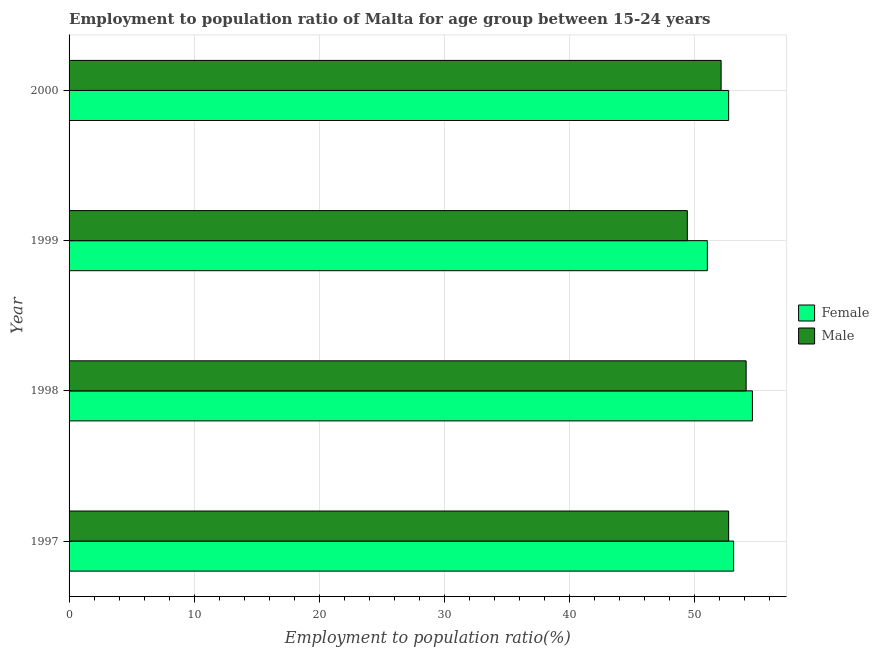How many different coloured bars are there?
Give a very brief answer. 2. Are the number of bars per tick equal to the number of legend labels?
Your answer should be very brief. Yes. How many bars are there on the 2nd tick from the top?
Offer a terse response. 2. How many bars are there on the 3rd tick from the bottom?
Your response must be concise. 2. In how many cases, is the number of bars for a given year not equal to the number of legend labels?
Provide a succinct answer. 0. What is the employment to population ratio(male) in 1997?
Offer a terse response. 52.7. Across all years, what is the maximum employment to population ratio(male)?
Your answer should be compact. 54.1. Across all years, what is the minimum employment to population ratio(female)?
Ensure brevity in your answer.  51. In which year was the employment to population ratio(female) maximum?
Your answer should be very brief. 1998. In which year was the employment to population ratio(male) minimum?
Provide a succinct answer. 1999. What is the total employment to population ratio(female) in the graph?
Your answer should be compact. 211.4. What is the difference between the employment to population ratio(male) in 1997 and that in 1998?
Ensure brevity in your answer.  -1.4. What is the difference between the employment to population ratio(female) in 2000 and the employment to population ratio(male) in 1998?
Provide a short and direct response. -1.4. What is the average employment to population ratio(male) per year?
Ensure brevity in your answer.  52.08. What is the ratio of the employment to population ratio(male) in 1999 to that in 2000?
Offer a terse response. 0.95. Is the employment to population ratio(male) in 1998 less than that in 1999?
Your answer should be compact. No. In how many years, is the employment to population ratio(male) greater than the average employment to population ratio(male) taken over all years?
Offer a very short reply. 3. What does the 2nd bar from the bottom in 1997 represents?
Provide a short and direct response. Male. How many bars are there?
Provide a succinct answer. 8. How many years are there in the graph?
Keep it short and to the point. 4. What is the difference between two consecutive major ticks on the X-axis?
Offer a very short reply. 10. Are the values on the major ticks of X-axis written in scientific E-notation?
Your answer should be very brief. No. Does the graph contain any zero values?
Ensure brevity in your answer.  No. How many legend labels are there?
Make the answer very short. 2. What is the title of the graph?
Provide a short and direct response. Employment to population ratio of Malta for age group between 15-24 years. Does "Females" appear as one of the legend labels in the graph?
Make the answer very short. No. What is the Employment to population ratio(%) of Female in 1997?
Keep it short and to the point. 53.1. What is the Employment to population ratio(%) in Male in 1997?
Provide a succinct answer. 52.7. What is the Employment to population ratio(%) in Female in 1998?
Make the answer very short. 54.6. What is the Employment to population ratio(%) of Male in 1998?
Your answer should be very brief. 54.1. What is the Employment to population ratio(%) in Female in 1999?
Your response must be concise. 51. What is the Employment to population ratio(%) in Male in 1999?
Your answer should be very brief. 49.4. What is the Employment to population ratio(%) in Female in 2000?
Make the answer very short. 52.7. What is the Employment to population ratio(%) in Male in 2000?
Offer a very short reply. 52.1. Across all years, what is the maximum Employment to population ratio(%) of Female?
Offer a very short reply. 54.6. Across all years, what is the maximum Employment to population ratio(%) in Male?
Offer a terse response. 54.1. Across all years, what is the minimum Employment to population ratio(%) in Male?
Your answer should be very brief. 49.4. What is the total Employment to population ratio(%) of Female in the graph?
Your response must be concise. 211.4. What is the total Employment to population ratio(%) of Male in the graph?
Offer a terse response. 208.3. What is the difference between the Employment to population ratio(%) in Female in 1997 and that in 1998?
Offer a very short reply. -1.5. What is the difference between the Employment to population ratio(%) in Male in 1997 and that in 1998?
Ensure brevity in your answer.  -1.4. What is the difference between the Employment to population ratio(%) in Female in 1997 and that in 1999?
Your answer should be compact. 2.1. What is the difference between the Employment to population ratio(%) of Male in 1997 and that in 1999?
Your response must be concise. 3.3. What is the difference between the Employment to population ratio(%) of Male in 1997 and that in 2000?
Offer a terse response. 0.6. What is the difference between the Employment to population ratio(%) in Female in 1998 and that in 1999?
Give a very brief answer. 3.6. What is the difference between the Employment to population ratio(%) of Female in 1999 and that in 2000?
Provide a short and direct response. -1.7. What is the difference between the Employment to population ratio(%) of Female in 1997 and the Employment to population ratio(%) of Male in 2000?
Ensure brevity in your answer.  1. What is the difference between the Employment to population ratio(%) in Female in 1998 and the Employment to population ratio(%) in Male in 2000?
Keep it short and to the point. 2.5. What is the difference between the Employment to population ratio(%) of Female in 1999 and the Employment to population ratio(%) of Male in 2000?
Provide a succinct answer. -1.1. What is the average Employment to population ratio(%) in Female per year?
Keep it short and to the point. 52.85. What is the average Employment to population ratio(%) in Male per year?
Provide a short and direct response. 52.08. In the year 1997, what is the difference between the Employment to population ratio(%) of Female and Employment to population ratio(%) of Male?
Ensure brevity in your answer.  0.4. In the year 1999, what is the difference between the Employment to population ratio(%) of Female and Employment to population ratio(%) of Male?
Provide a succinct answer. 1.6. What is the ratio of the Employment to population ratio(%) in Female in 1997 to that in 1998?
Keep it short and to the point. 0.97. What is the ratio of the Employment to population ratio(%) of Male in 1997 to that in 1998?
Offer a terse response. 0.97. What is the ratio of the Employment to population ratio(%) of Female in 1997 to that in 1999?
Your answer should be very brief. 1.04. What is the ratio of the Employment to population ratio(%) in Male in 1997 to that in 1999?
Your response must be concise. 1.07. What is the ratio of the Employment to population ratio(%) of Female in 1997 to that in 2000?
Provide a short and direct response. 1.01. What is the ratio of the Employment to population ratio(%) in Male in 1997 to that in 2000?
Make the answer very short. 1.01. What is the ratio of the Employment to population ratio(%) in Female in 1998 to that in 1999?
Provide a succinct answer. 1.07. What is the ratio of the Employment to population ratio(%) in Male in 1998 to that in 1999?
Offer a very short reply. 1.1. What is the ratio of the Employment to population ratio(%) of Female in 1998 to that in 2000?
Ensure brevity in your answer.  1.04. What is the ratio of the Employment to population ratio(%) of Male in 1998 to that in 2000?
Offer a terse response. 1.04. What is the ratio of the Employment to population ratio(%) in Female in 1999 to that in 2000?
Make the answer very short. 0.97. What is the ratio of the Employment to population ratio(%) in Male in 1999 to that in 2000?
Offer a terse response. 0.95. What is the difference between the highest and the second highest Employment to population ratio(%) of Male?
Provide a succinct answer. 1.4. What is the difference between the highest and the lowest Employment to population ratio(%) of Male?
Ensure brevity in your answer.  4.7. 